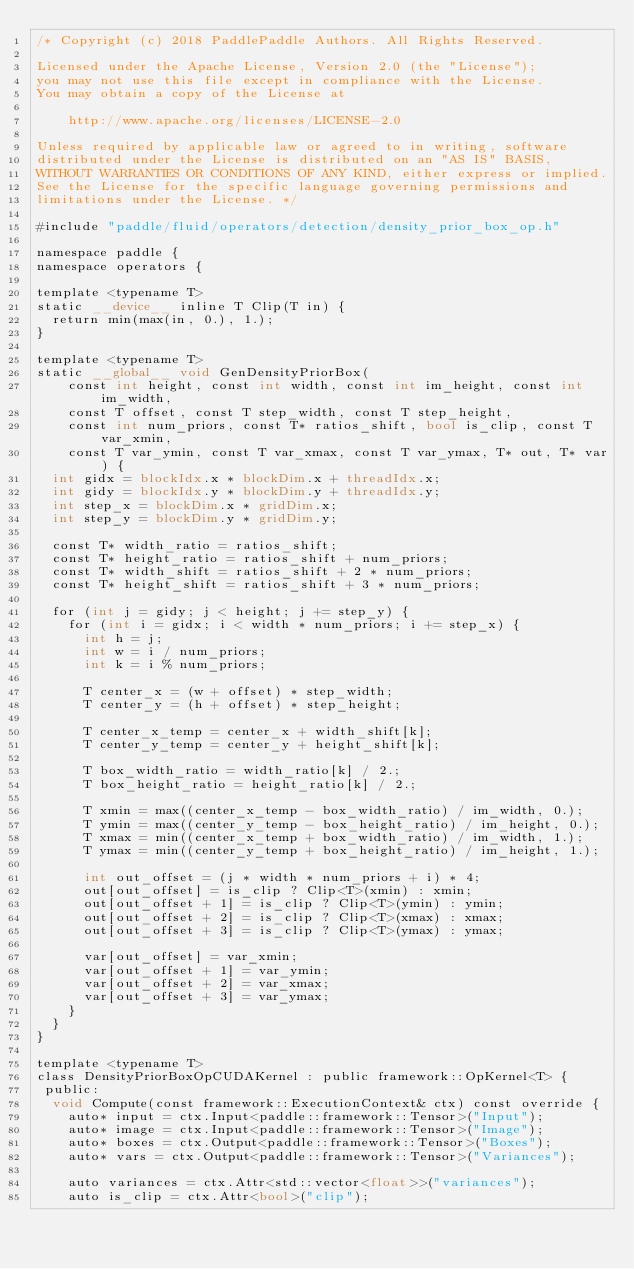<code> <loc_0><loc_0><loc_500><loc_500><_Cuda_>/* Copyright (c) 2018 PaddlePaddle Authors. All Rights Reserved.

Licensed under the Apache License, Version 2.0 (the "License");
you may not use this file except in compliance with the License.
You may obtain a copy of the License at

    http://www.apache.org/licenses/LICENSE-2.0

Unless required by applicable law or agreed to in writing, software
distributed under the License is distributed on an "AS IS" BASIS,
WITHOUT WARRANTIES OR CONDITIONS OF ANY KIND, either express or implied.
See the License for the specific language governing permissions and
limitations under the License. */

#include "paddle/fluid/operators/detection/density_prior_box_op.h"

namespace paddle {
namespace operators {

template <typename T>
static __device__ inline T Clip(T in) {
  return min(max(in, 0.), 1.);
}

template <typename T>
static __global__ void GenDensityPriorBox(
    const int height, const int width, const int im_height, const int im_width,
    const T offset, const T step_width, const T step_height,
    const int num_priors, const T* ratios_shift, bool is_clip, const T var_xmin,
    const T var_ymin, const T var_xmax, const T var_ymax, T* out, T* var) {
  int gidx = blockIdx.x * blockDim.x + threadIdx.x;
  int gidy = blockIdx.y * blockDim.y + threadIdx.y;
  int step_x = blockDim.x * gridDim.x;
  int step_y = blockDim.y * gridDim.y;

  const T* width_ratio = ratios_shift;
  const T* height_ratio = ratios_shift + num_priors;
  const T* width_shift = ratios_shift + 2 * num_priors;
  const T* height_shift = ratios_shift + 3 * num_priors;

  for (int j = gidy; j < height; j += step_y) {
    for (int i = gidx; i < width * num_priors; i += step_x) {
      int h = j;
      int w = i / num_priors;
      int k = i % num_priors;

      T center_x = (w + offset) * step_width;
      T center_y = (h + offset) * step_height;

      T center_x_temp = center_x + width_shift[k];
      T center_y_temp = center_y + height_shift[k];

      T box_width_ratio = width_ratio[k] / 2.;
      T box_height_ratio = height_ratio[k] / 2.;

      T xmin = max((center_x_temp - box_width_ratio) / im_width, 0.);
      T ymin = max((center_y_temp - box_height_ratio) / im_height, 0.);
      T xmax = min((center_x_temp + box_width_ratio) / im_width, 1.);
      T ymax = min((center_y_temp + box_height_ratio) / im_height, 1.);

      int out_offset = (j * width * num_priors + i) * 4;
      out[out_offset] = is_clip ? Clip<T>(xmin) : xmin;
      out[out_offset + 1] = is_clip ? Clip<T>(ymin) : ymin;
      out[out_offset + 2] = is_clip ? Clip<T>(xmax) : xmax;
      out[out_offset + 3] = is_clip ? Clip<T>(ymax) : ymax;

      var[out_offset] = var_xmin;
      var[out_offset + 1] = var_ymin;
      var[out_offset + 2] = var_xmax;
      var[out_offset + 3] = var_ymax;
    }
  }
}

template <typename T>
class DensityPriorBoxOpCUDAKernel : public framework::OpKernel<T> {
 public:
  void Compute(const framework::ExecutionContext& ctx) const override {
    auto* input = ctx.Input<paddle::framework::Tensor>("Input");
    auto* image = ctx.Input<paddle::framework::Tensor>("Image");
    auto* boxes = ctx.Output<paddle::framework::Tensor>("Boxes");
    auto* vars = ctx.Output<paddle::framework::Tensor>("Variances");

    auto variances = ctx.Attr<std::vector<float>>("variances");
    auto is_clip = ctx.Attr<bool>("clip");
</code> 